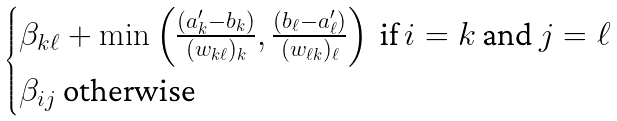Convert formula to latex. <formula><loc_0><loc_0><loc_500><loc_500>\begin{cases} \beta _ { k \ell } + \min \left ( \frac { ( a ^ { \prime } _ { k } - b _ { k } ) } { ( w _ { k \ell } ) _ { k } } , \frac { ( b _ { \ell } - a ^ { \prime } _ { \ell } ) } { ( w _ { \ell k } ) _ { \ell } } \right ) \text { if $i = k$ and $j = \ell$} \\ \beta _ { i j } \text { otherwise} \end{cases}</formula> 